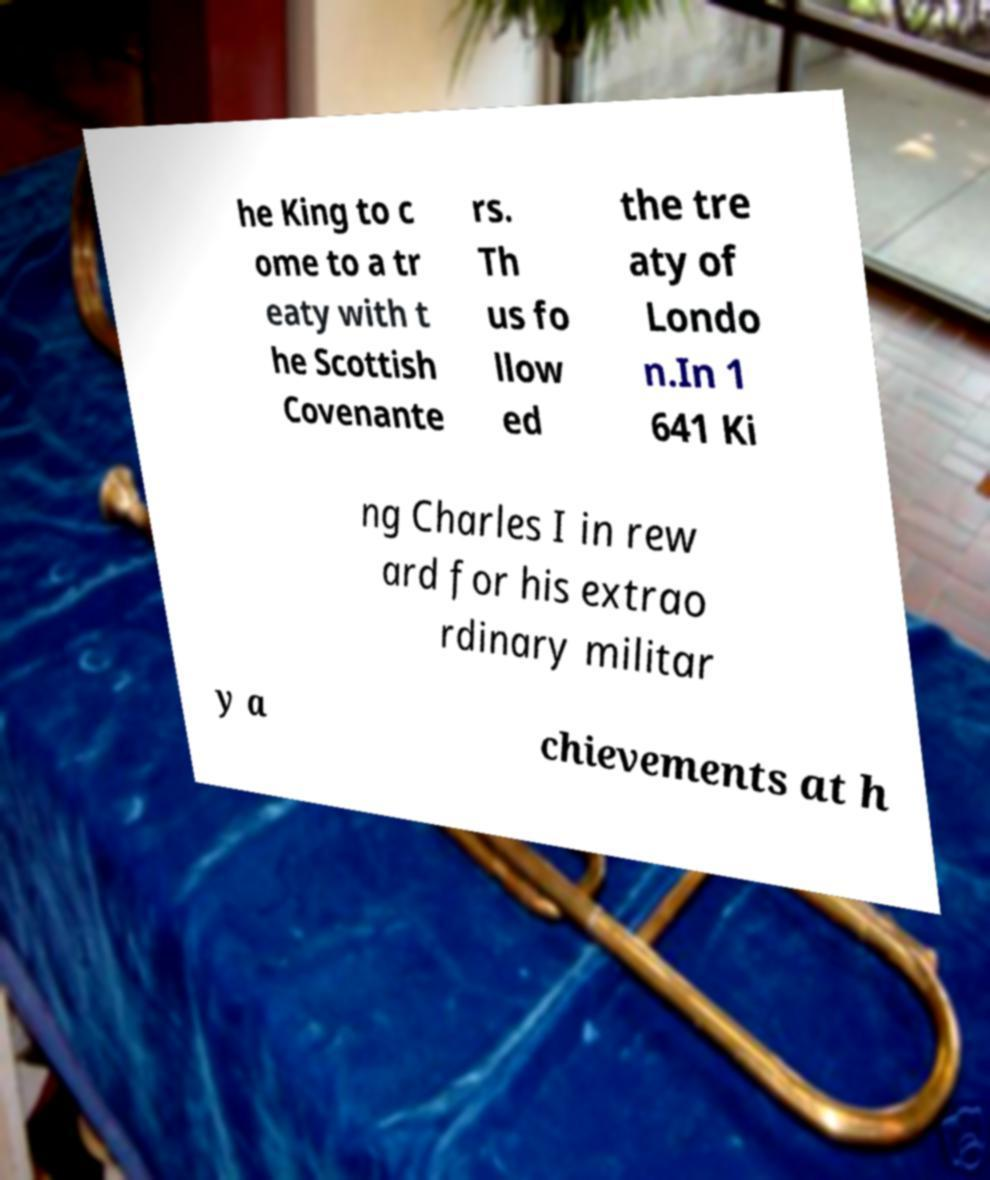Can you accurately transcribe the text from the provided image for me? he King to c ome to a tr eaty with t he Scottish Covenante rs. Th us fo llow ed the tre aty of Londo n.In 1 641 Ki ng Charles I in rew ard for his extrao rdinary militar y a chievements at h 